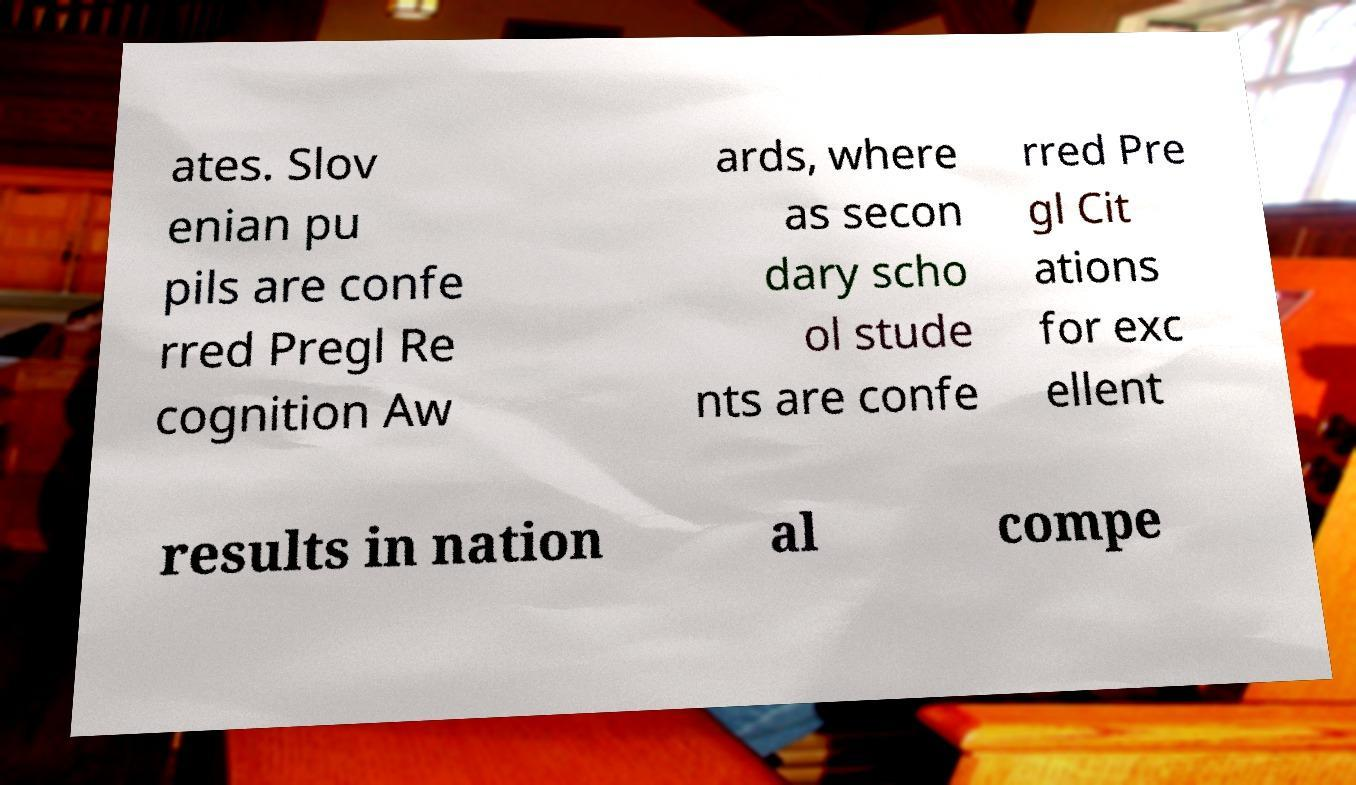Can you read and provide the text displayed in the image?This photo seems to have some interesting text. Can you extract and type it out for me? ates. Slov enian pu pils are confe rred Pregl Re cognition Aw ards, where as secon dary scho ol stude nts are confe rred Pre gl Cit ations for exc ellent results in nation al compe 